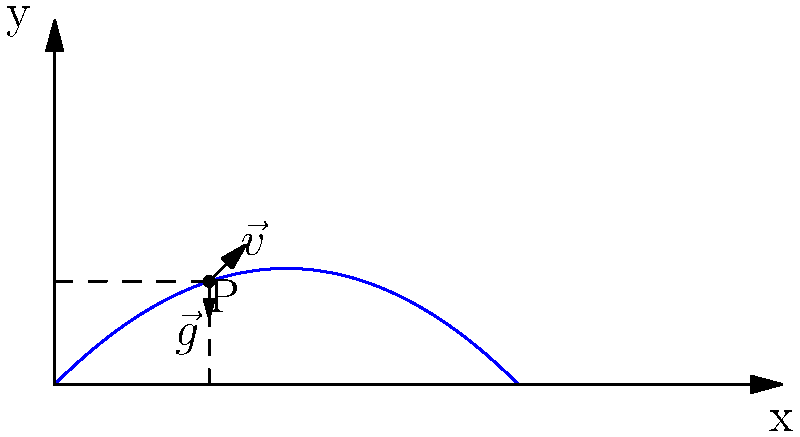As a football coach, you're analyzing the trajectory of a kicked ball. The ball is kicked with an initial velocity of 25 m/s at an angle of 45° to the horizontal. At point P on the trajectory, what is the ratio of the ball's horizontal velocity to its initial velocity? Let's approach this step-by-step:

1) The initial velocity components are:
   $v_{0x} = v_0 \cos \theta = 25 \cos 45° = 25 \cdot \frac{\sqrt{2}}{2} \approx 17.68$ m/s
   $v_{0y} = v_0 \sin \theta = 25 \sin 45° = 25 \cdot \frac{\sqrt{2}}{2} \approx 17.68$ m/s

2) In projectile motion, the horizontal velocity remains constant throughout the trajectory due to the absence of horizontal forces (neglecting air resistance). Therefore, at any point P:
   $v_x = v_{0x} = 25 \cos 45°$

3) The ratio of the ball's horizontal velocity to its initial velocity is:

   $\frac{v_x}{v_0} = \frac{25 \cos 45°}{25} = \cos 45°$

4) We know that $\cos 45° = \frac{\sqrt{2}}{2} \approx 0.707$

Thus, the ratio of the ball's horizontal velocity to its initial velocity at point P (and at any point on the trajectory) is $\frac{\sqrt{2}}{2}$ or approximately 0.707.
Answer: $\frac{\sqrt{2}}{2}$ or 0.707 